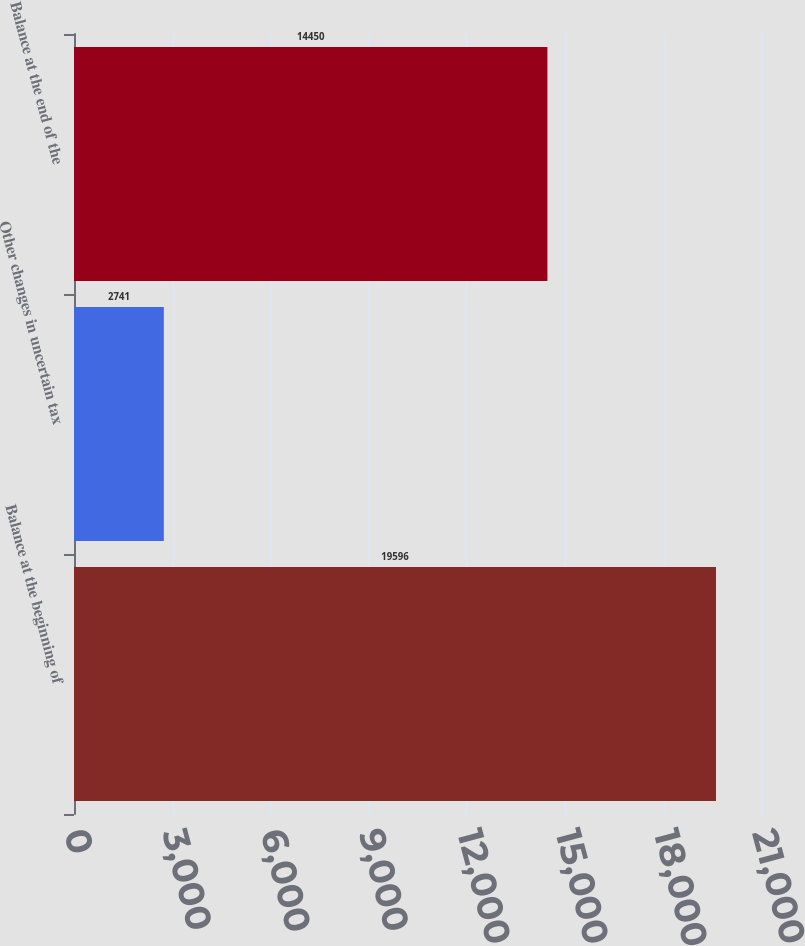Convert chart. <chart><loc_0><loc_0><loc_500><loc_500><bar_chart><fcel>Balance at the beginning of<fcel>Other changes in uncertain tax<fcel>Balance at the end of the<nl><fcel>19596<fcel>2741<fcel>14450<nl></chart> 